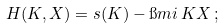Convert formula to latex. <formula><loc_0><loc_0><loc_500><loc_500>H ( K , X ) = s ( K ) - \i m i \, K X \, ;</formula> 